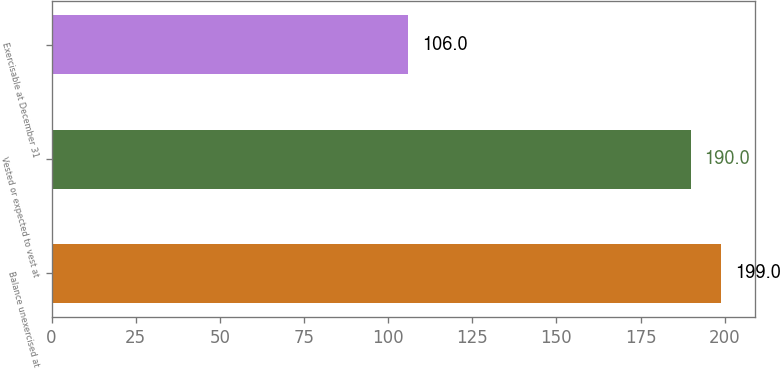Convert chart. <chart><loc_0><loc_0><loc_500><loc_500><bar_chart><fcel>Balance unexercised at<fcel>Vested or expected to vest at<fcel>Exercisable at December 31<nl><fcel>199<fcel>190<fcel>106<nl></chart> 